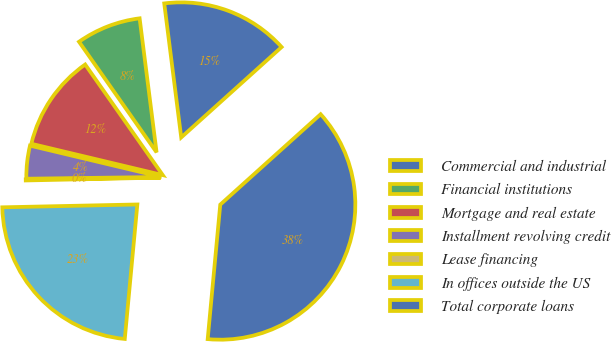Convert chart to OTSL. <chart><loc_0><loc_0><loc_500><loc_500><pie_chart><fcel>Commercial and industrial<fcel>Financial institutions<fcel>Mortgage and real estate<fcel>Installment revolving credit<fcel>Lease financing<fcel>In offices outside the US<fcel>Total corporate loans<nl><fcel>15.34%<fcel>7.73%<fcel>11.54%<fcel>3.93%<fcel>0.13%<fcel>23.18%<fcel>38.15%<nl></chart> 